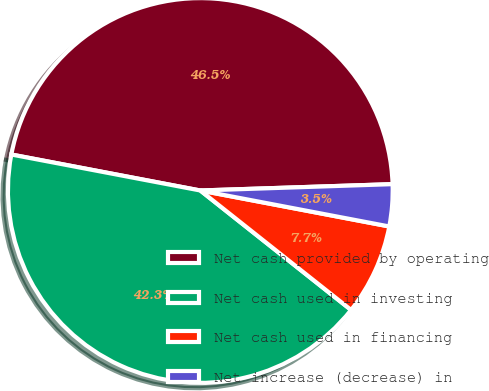Convert chart to OTSL. <chart><loc_0><loc_0><loc_500><loc_500><pie_chart><fcel>Net cash provided by operating<fcel>Net cash used in investing<fcel>Net cash used in financing<fcel>Net increase (decrease) in<nl><fcel>46.48%<fcel>42.33%<fcel>7.67%<fcel>3.52%<nl></chart> 